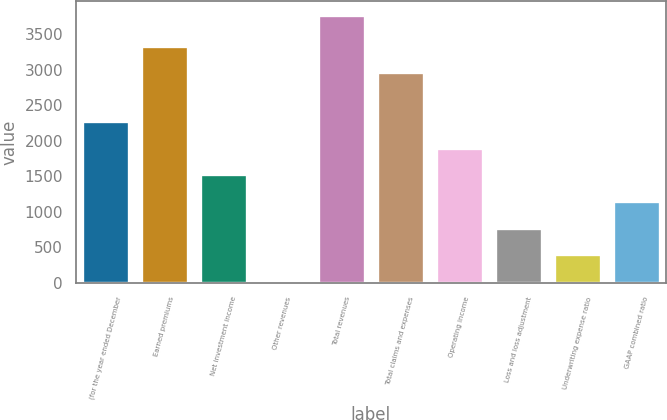Convert chart to OTSL. <chart><loc_0><loc_0><loc_500><loc_500><bar_chart><fcel>(for the year ended December<fcel>Earned premiums<fcel>Net investment income<fcel>Other revenues<fcel>Total revenues<fcel>Total claims and expenses<fcel>Operating income<fcel>Loss and loss adjustment<fcel>Underwriting expense ratio<fcel>GAAP combined ratio<nl><fcel>2276<fcel>3343<fcel>1526<fcel>26<fcel>3776<fcel>2968<fcel>1901<fcel>776<fcel>401<fcel>1151<nl></chart> 